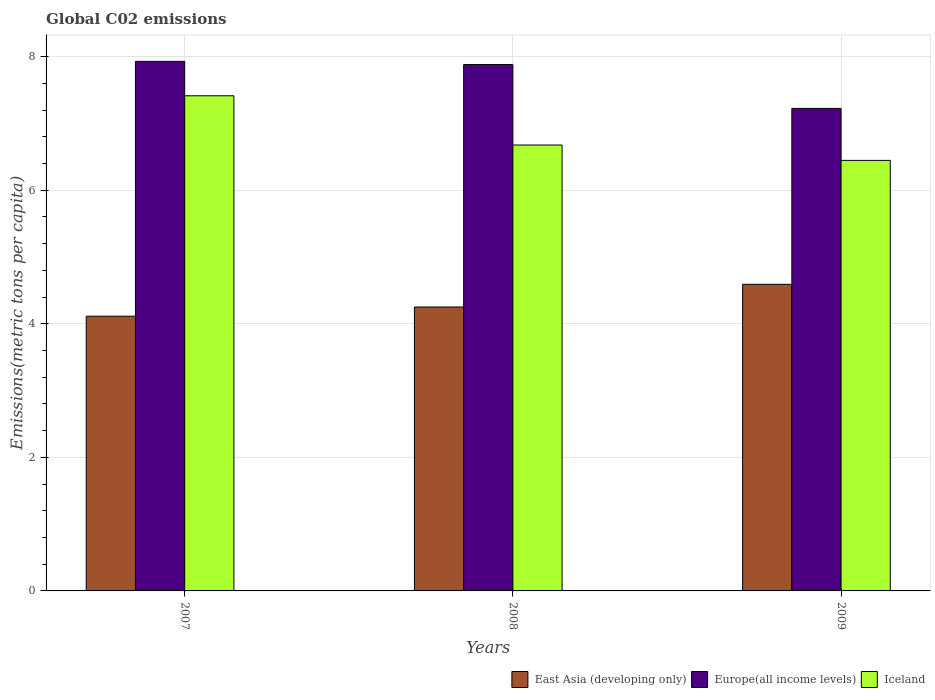Are the number of bars per tick equal to the number of legend labels?
Give a very brief answer. Yes. How many bars are there on the 3rd tick from the left?
Make the answer very short. 3. What is the amount of CO2 emitted in in Europe(all income levels) in 2008?
Offer a terse response. 7.88. Across all years, what is the maximum amount of CO2 emitted in in Europe(all income levels)?
Provide a succinct answer. 7.93. Across all years, what is the minimum amount of CO2 emitted in in Iceland?
Your answer should be very brief. 6.45. In which year was the amount of CO2 emitted in in East Asia (developing only) maximum?
Provide a succinct answer. 2009. What is the total amount of CO2 emitted in in Europe(all income levels) in the graph?
Your answer should be compact. 23.04. What is the difference between the amount of CO2 emitted in in East Asia (developing only) in 2008 and that in 2009?
Your answer should be compact. -0.34. What is the difference between the amount of CO2 emitted in in Iceland in 2007 and the amount of CO2 emitted in in Europe(all income levels) in 2008?
Ensure brevity in your answer.  -0.47. What is the average amount of CO2 emitted in in East Asia (developing only) per year?
Provide a short and direct response. 4.32. In the year 2007, what is the difference between the amount of CO2 emitted in in East Asia (developing only) and amount of CO2 emitted in in Iceland?
Your answer should be very brief. -3.3. In how many years, is the amount of CO2 emitted in in East Asia (developing only) greater than 4.8 metric tons per capita?
Provide a short and direct response. 0. What is the ratio of the amount of CO2 emitted in in Europe(all income levels) in 2007 to that in 2009?
Provide a succinct answer. 1.1. Is the difference between the amount of CO2 emitted in in East Asia (developing only) in 2007 and 2009 greater than the difference between the amount of CO2 emitted in in Iceland in 2007 and 2009?
Give a very brief answer. No. What is the difference between the highest and the second highest amount of CO2 emitted in in East Asia (developing only)?
Your answer should be very brief. 0.34. What is the difference between the highest and the lowest amount of CO2 emitted in in Europe(all income levels)?
Your answer should be compact. 0.7. Is the sum of the amount of CO2 emitted in in Europe(all income levels) in 2007 and 2009 greater than the maximum amount of CO2 emitted in in East Asia (developing only) across all years?
Provide a succinct answer. Yes. What does the 2nd bar from the right in 2008 represents?
Provide a short and direct response. Europe(all income levels). Is it the case that in every year, the sum of the amount of CO2 emitted in in East Asia (developing only) and amount of CO2 emitted in in Iceland is greater than the amount of CO2 emitted in in Europe(all income levels)?
Ensure brevity in your answer.  Yes. How many bars are there?
Your answer should be compact. 9. Are the values on the major ticks of Y-axis written in scientific E-notation?
Give a very brief answer. No. What is the title of the graph?
Provide a short and direct response. Global C02 emissions. Does "High income" appear as one of the legend labels in the graph?
Your answer should be compact. No. What is the label or title of the Y-axis?
Provide a short and direct response. Emissions(metric tons per capita). What is the Emissions(metric tons per capita) in East Asia (developing only) in 2007?
Your answer should be compact. 4.11. What is the Emissions(metric tons per capita) of Europe(all income levels) in 2007?
Ensure brevity in your answer.  7.93. What is the Emissions(metric tons per capita) in Iceland in 2007?
Your response must be concise. 7.41. What is the Emissions(metric tons per capita) of East Asia (developing only) in 2008?
Ensure brevity in your answer.  4.25. What is the Emissions(metric tons per capita) in Europe(all income levels) in 2008?
Offer a very short reply. 7.88. What is the Emissions(metric tons per capita) in Iceland in 2008?
Your answer should be very brief. 6.68. What is the Emissions(metric tons per capita) of East Asia (developing only) in 2009?
Ensure brevity in your answer.  4.59. What is the Emissions(metric tons per capita) of Europe(all income levels) in 2009?
Keep it short and to the point. 7.23. What is the Emissions(metric tons per capita) in Iceland in 2009?
Ensure brevity in your answer.  6.45. Across all years, what is the maximum Emissions(metric tons per capita) in East Asia (developing only)?
Keep it short and to the point. 4.59. Across all years, what is the maximum Emissions(metric tons per capita) in Europe(all income levels)?
Provide a succinct answer. 7.93. Across all years, what is the maximum Emissions(metric tons per capita) of Iceland?
Your answer should be very brief. 7.41. Across all years, what is the minimum Emissions(metric tons per capita) of East Asia (developing only)?
Provide a short and direct response. 4.11. Across all years, what is the minimum Emissions(metric tons per capita) in Europe(all income levels)?
Keep it short and to the point. 7.23. Across all years, what is the minimum Emissions(metric tons per capita) in Iceland?
Keep it short and to the point. 6.45. What is the total Emissions(metric tons per capita) in East Asia (developing only) in the graph?
Your answer should be very brief. 12.96. What is the total Emissions(metric tons per capita) in Europe(all income levels) in the graph?
Provide a succinct answer. 23.04. What is the total Emissions(metric tons per capita) in Iceland in the graph?
Give a very brief answer. 20.54. What is the difference between the Emissions(metric tons per capita) of East Asia (developing only) in 2007 and that in 2008?
Provide a succinct answer. -0.14. What is the difference between the Emissions(metric tons per capita) of Europe(all income levels) in 2007 and that in 2008?
Make the answer very short. 0.05. What is the difference between the Emissions(metric tons per capita) in Iceland in 2007 and that in 2008?
Provide a short and direct response. 0.74. What is the difference between the Emissions(metric tons per capita) in East Asia (developing only) in 2007 and that in 2009?
Your response must be concise. -0.48. What is the difference between the Emissions(metric tons per capita) in Europe(all income levels) in 2007 and that in 2009?
Provide a short and direct response. 0.7. What is the difference between the Emissions(metric tons per capita) of Iceland in 2007 and that in 2009?
Your answer should be very brief. 0.97. What is the difference between the Emissions(metric tons per capita) of East Asia (developing only) in 2008 and that in 2009?
Ensure brevity in your answer.  -0.34. What is the difference between the Emissions(metric tons per capita) in Europe(all income levels) in 2008 and that in 2009?
Your answer should be compact. 0.66. What is the difference between the Emissions(metric tons per capita) in Iceland in 2008 and that in 2009?
Your answer should be very brief. 0.23. What is the difference between the Emissions(metric tons per capita) in East Asia (developing only) in 2007 and the Emissions(metric tons per capita) in Europe(all income levels) in 2008?
Your response must be concise. -3.77. What is the difference between the Emissions(metric tons per capita) of East Asia (developing only) in 2007 and the Emissions(metric tons per capita) of Iceland in 2008?
Give a very brief answer. -2.56. What is the difference between the Emissions(metric tons per capita) in Europe(all income levels) in 2007 and the Emissions(metric tons per capita) in Iceland in 2008?
Your answer should be very brief. 1.25. What is the difference between the Emissions(metric tons per capita) in East Asia (developing only) in 2007 and the Emissions(metric tons per capita) in Europe(all income levels) in 2009?
Your answer should be very brief. -3.11. What is the difference between the Emissions(metric tons per capita) of East Asia (developing only) in 2007 and the Emissions(metric tons per capita) of Iceland in 2009?
Provide a short and direct response. -2.33. What is the difference between the Emissions(metric tons per capita) in Europe(all income levels) in 2007 and the Emissions(metric tons per capita) in Iceland in 2009?
Your answer should be compact. 1.48. What is the difference between the Emissions(metric tons per capita) in East Asia (developing only) in 2008 and the Emissions(metric tons per capita) in Europe(all income levels) in 2009?
Offer a very short reply. -2.97. What is the difference between the Emissions(metric tons per capita) in East Asia (developing only) in 2008 and the Emissions(metric tons per capita) in Iceland in 2009?
Provide a short and direct response. -2.2. What is the difference between the Emissions(metric tons per capita) of Europe(all income levels) in 2008 and the Emissions(metric tons per capita) of Iceland in 2009?
Your answer should be very brief. 1.43. What is the average Emissions(metric tons per capita) of East Asia (developing only) per year?
Make the answer very short. 4.32. What is the average Emissions(metric tons per capita) in Europe(all income levels) per year?
Make the answer very short. 7.68. What is the average Emissions(metric tons per capita) in Iceland per year?
Offer a very short reply. 6.85. In the year 2007, what is the difference between the Emissions(metric tons per capita) of East Asia (developing only) and Emissions(metric tons per capita) of Europe(all income levels)?
Keep it short and to the point. -3.82. In the year 2007, what is the difference between the Emissions(metric tons per capita) of East Asia (developing only) and Emissions(metric tons per capita) of Iceland?
Provide a short and direct response. -3.3. In the year 2007, what is the difference between the Emissions(metric tons per capita) in Europe(all income levels) and Emissions(metric tons per capita) in Iceland?
Give a very brief answer. 0.52. In the year 2008, what is the difference between the Emissions(metric tons per capita) in East Asia (developing only) and Emissions(metric tons per capita) in Europe(all income levels)?
Offer a terse response. -3.63. In the year 2008, what is the difference between the Emissions(metric tons per capita) in East Asia (developing only) and Emissions(metric tons per capita) in Iceland?
Your answer should be compact. -2.43. In the year 2008, what is the difference between the Emissions(metric tons per capita) of Europe(all income levels) and Emissions(metric tons per capita) of Iceland?
Your answer should be compact. 1.2. In the year 2009, what is the difference between the Emissions(metric tons per capita) in East Asia (developing only) and Emissions(metric tons per capita) in Europe(all income levels)?
Your response must be concise. -2.63. In the year 2009, what is the difference between the Emissions(metric tons per capita) of East Asia (developing only) and Emissions(metric tons per capita) of Iceland?
Offer a very short reply. -1.86. In the year 2009, what is the difference between the Emissions(metric tons per capita) of Europe(all income levels) and Emissions(metric tons per capita) of Iceland?
Give a very brief answer. 0.78. What is the ratio of the Emissions(metric tons per capita) in East Asia (developing only) in 2007 to that in 2008?
Provide a short and direct response. 0.97. What is the ratio of the Emissions(metric tons per capita) in Europe(all income levels) in 2007 to that in 2008?
Offer a very short reply. 1.01. What is the ratio of the Emissions(metric tons per capita) of Iceland in 2007 to that in 2008?
Provide a succinct answer. 1.11. What is the ratio of the Emissions(metric tons per capita) of East Asia (developing only) in 2007 to that in 2009?
Keep it short and to the point. 0.9. What is the ratio of the Emissions(metric tons per capita) of Europe(all income levels) in 2007 to that in 2009?
Give a very brief answer. 1.1. What is the ratio of the Emissions(metric tons per capita) in Iceland in 2007 to that in 2009?
Offer a terse response. 1.15. What is the ratio of the Emissions(metric tons per capita) of East Asia (developing only) in 2008 to that in 2009?
Provide a succinct answer. 0.93. What is the ratio of the Emissions(metric tons per capita) in Europe(all income levels) in 2008 to that in 2009?
Offer a terse response. 1.09. What is the ratio of the Emissions(metric tons per capita) of Iceland in 2008 to that in 2009?
Your answer should be compact. 1.04. What is the difference between the highest and the second highest Emissions(metric tons per capita) in East Asia (developing only)?
Keep it short and to the point. 0.34. What is the difference between the highest and the second highest Emissions(metric tons per capita) of Europe(all income levels)?
Offer a terse response. 0.05. What is the difference between the highest and the second highest Emissions(metric tons per capita) in Iceland?
Ensure brevity in your answer.  0.74. What is the difference between the highest and the lowest Emissions(metric tons per capita) in East Asia (developing only)?
Make the answer very short. 0.48. What is the difference between the highest and the lowest Emissions(metric tons per capita) of Europe(all income levels)?
Your response must be concise. 0.7. What is the difference between the highest and the lowest Emissions(metric tons per capita) in Iceland?
Offer a terse response. 0.97. 